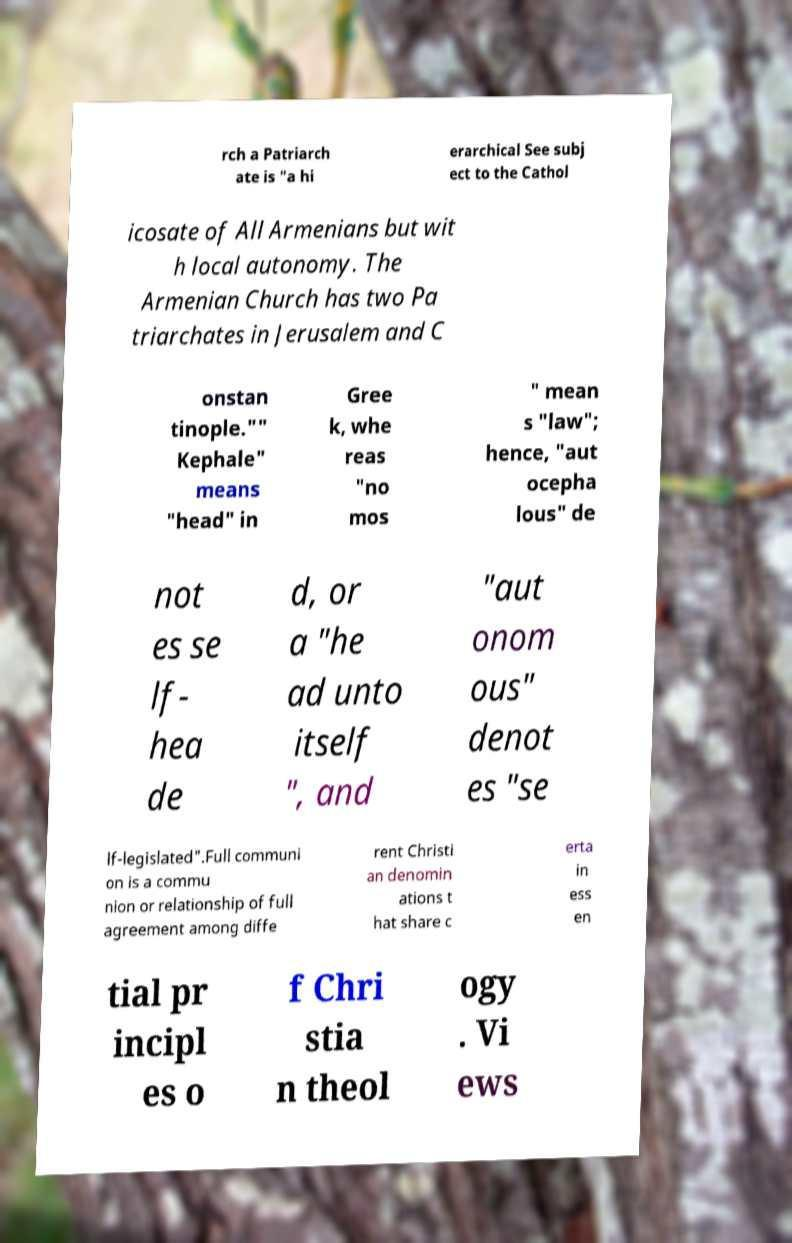Please read and relay the text visible in this image. What does it say? rch a Patriarch ate is "a hi erarchical See subj ect to the Cathol icosate of All Armenians but wit h local autonomy. The Armenian Church has two Pa triarchates in Jerusalem and C onstan tinople."" Kephale" means "head" in Gree k, whe reas "no mos " mean s "law"; hence, "aut ocepha lous" de not es se lf- hea de d, or a "he ad unto itself ", and "aut onom ous" denot es "se lf-legislated".Full communi on is a commu nion or relationship of full agreement among diffe rent Christi an denomin ations t hat share c erta in ess en tial pr incipl es o f Chri stia n theol ogy . Vi ews 